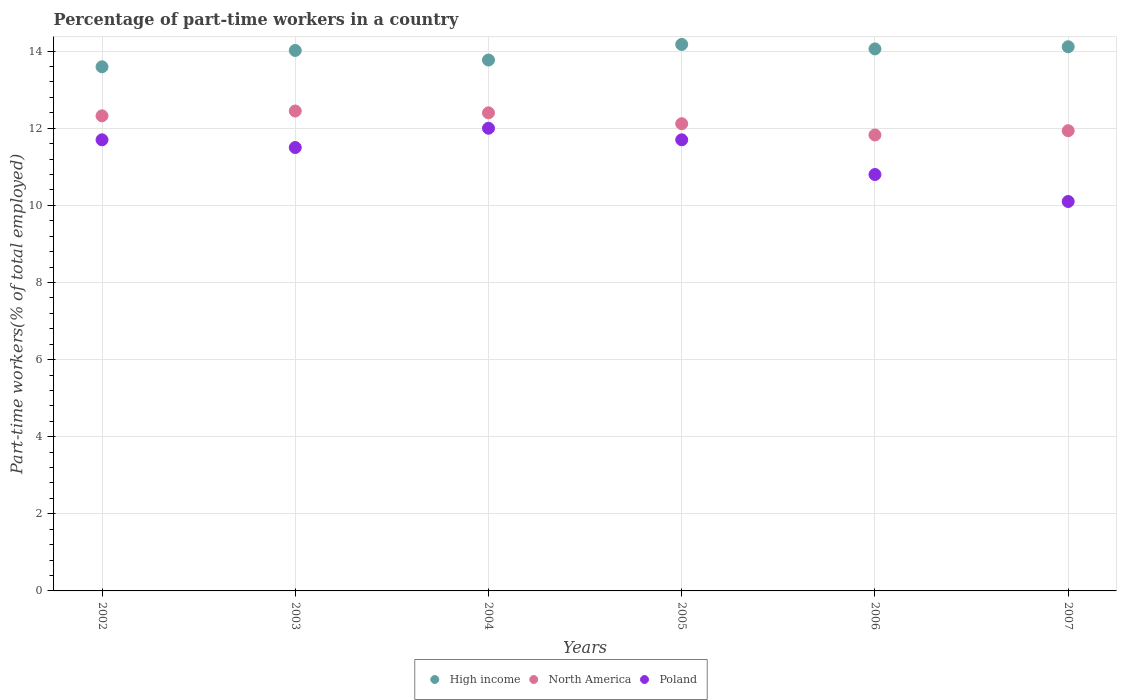Is the number of dotlines equal to the number of legend labels?
Give a very brief answer. Yes. Across all years, what is the minimum percentage of part-time workers in Poland?
Make the answer very short. 10.1. In which year was the percentage of part-time workers in Poland minimum?
Your answer should be very brief. 2007. What is the total percentage of part-time workers in Poland in the graph?
Make the answer very short. 67.8. What is the difference between the percentage of part-time workers in Poland in 2005 and that in 2006?
Make the answer very short. 0.9. What is the difference between the percentage of part-time workers in North America in 2006 and the percentage of part-time workers in Poland in 2004?
Your answer should be compact. -0.17. What is the average percentage of part-time workers in Poland per year?
Ensure brevity in your answer.  11.3. In the year 2007, what is the difference between the percentage of part-time workers in High income and percentage of part-time workers in Poland?
Your response must be concise. 4.01. In how many years, is the percentage of part-time workers in North America greater than 2.8 %?
Ensure brevity in your answer.  6. What is the ratio of the percentage of part-time workers in Poland in 2003 to that in 2006?
Make the answer very short. 1.06. What is the difference between the highest and the second highest percentage of part-time workers in Poland?
Provide a short and direct response. 0.3. What is the difference between the highest and the lowest percentage of part-time workers in Poland?
Offer a very short reply. 1.9. Is it the case that in every year, the sum of the percentage of part-time workers in North America and percentage of part-time workers in Poland  is greater than the percentage of part-time workers in High income?
Keep it short and to the point. Yes. Is the percentage of part-time workers in Poland strictly greater than the percentage of part-time workers in High income over the years?
Offer a very short reply. No. Is the percentage of part-time workers in Poland strictly less than the percentage of part-time workers in High income over the years?
Make the answer very short. Yes. How many dotlines are there?
Provide a succinct answer. 3. How many years are there in the graph?
Provide a short and direct response. 6. Does the graph contain grids?
Provide a short and direct response. Yes. Where does the legend appear in the graph?
Provide a succinct answer. Bottom center. How are the legend labels stacked?
Offer a terse response. Horizontal. What is the title of the graph?
Keep it short and to the point. Percentage of part-time workers in a country. Does "Brunei Darussalam" appear as one of the legend labels in the graph?
Ensure brevity in your answer.  No. What is the label or title of the Y-axis?
Your answer should be compact. Part-time workers(% of total employed). What is the Part-time workers(% of total employed) of High income in 2002?
Your answer should be compact. 13.59. What is the Part-time workers(% of total employed) of North America in 2002?
Offer a terse response. 12.32. What is the Part-time workers(% of total employed) of Poland in 2002?
Provide a short and direct response. 11.7. What is the Part-time workers(% of total employed) in High income in 2003?
Keep it short and to the point. 14.02. What is the Part-time workers(% of total employed) in North America in 2003?
Offer a terse response. 12.45. What is the Part-time workers(% of total employed) in Poland in 2003?
Your answer should be compact. 11.5. What is the Part-time workers(% of total employed) in High income in 2004?
Your answer should be very brief. 13.77. What is the Part-time workers(% of total employed) of North America in 2004?
Provide a succinct answer. 12.4. What is the Part-time workers(% of total employed) in High income in 2005?
Your response must be concise. 14.17. What is the Part-time workers(% of total employed) of North America in 2005?
Provide a short and direct response. 12.12. What is the Part-time workers(% of total employed) in Poland in 2005?
Keep it short and to the point. 11.7. What is the Part-time workers(% of total employed) of High income in 2006?
Provide a short and direct response. 14.06. What is the Part-time workers(% of total employed) in North America in 2006?
Offer a terse response. 11.83. What is the Part-time workers(% of total employed) in Poland in 2006?
Make the answer very short. 10.8. What is the Part-time workers(% of total employed) in High income in 2007?
Give a very brief answer. 14.11. What is the Part-time workers(% of total employed) in North America in 2007?
Your answer should be very brief. 11.94. What is the Part-time workers(% of total employed) in Poland in 2007?
Provide a short and direct response. 10.1. Across all years, what is the maximum Part-time workers(% of total employed) in High income?
Your response must be concise. 14.17. Across all years, what is the maximum Part-time workers(% of total employed) of North America?
Provide a short and direct response. 12.45. Across all years, what is the maximum Part-time workers(% of total employed) in Poland?
Provide a succinct answer. 12. Across all years, what is the minimum Part-time workers(% of total employed) in High income?
Give a very brief answer. 13.59. Across all years, what is the minimum Part-time workers(% of total employed) of North America?
Give a very brief answer. 11.83. Across all years, what is the minimum Part-time workers(% of total employed) in Poland?
Make the answer very short. 10.1. What is the total Part-time workers(% of total employed) of High income in the graph?
Provide a short and direct response. 83.73. What is the total Part-time workers(% of total employed) of North America in the graph?
Your response must be concise. 73.05. What is the total Part-time workers(% of total employed) in Poland in the graph?
Keep it short and to the point. 67.8. What is the difference between the Part-time workers(% of total employed) in High income in 2002 and that in 2003?
Offer a very short reply. -0.42. What is the difference between the Part-time workers(% of total employed) of North America in 2002 and that in 2003?
Give a very brief answer. -0.13. What is the difference between the Part-time workers(% of total employed) of Poland in 2002 and that in 2003?
Your response must be concise. 0.2. What is the difference between the Part-time workers(% of total employed) of High income in 2002 and that in 2004?
Give a very brief answer. -0.18. What is the difference between the Part-time workers(% of total employed) in North America in 2002 and that in 2004?
Give a very brief answer. -0.08. What is the difference between the Part-time workers(% of total employed) in Poland in 2002 and that in 2004?
Keep it short and to the point. -0.3. What is the difference between the Part-time workers(% of total employed) in High income in 2002 and that in 2005?
Keep it short and to the point. -0.58. What is the difference between the Part-time workers(% of total employed) in North America in 2002 and that in 2005?
Offer a terse response. 0.2. What is the difference between the Part-time workers(% of total employed) of Poland in 2002 and that in 2005?
Offer a very short reply. 0. What is the difference between the Part-time workers(% of total employed) in High income in 2002 and that in 2006?
Your response must be concise. -0.46. What is the difference between the Part-time workers(% of total employed) of North America in 2002 and that in 2006?
Your response must be concise. 0.5. What is the difference between the Part-time workers(% of total employed) in Poland in 2002 and that in 2006?
Your answer should be very brief. 0.9. What is the difference between the Part-time workers(% of total employed) of High income in 2002 and that in 2007?
Offer a terse response. -0.52. What is the difference between the Part-time workers(% of total employed) in North America in 2002 and that in 2007?
Ensure brevity in your answer.  0.39. What is the difference between the Part-time workers(% of total employed) in High income in 2003 and that in 2004?
Your response must be concise. 0.25. What is the difference between the Part-time workers(% of total employed) of North America in 2003 and that in 2004?
Your answer should be very brief. 0.05. What is the difference between the Part-time workers(% of total employed) of Poland in 2003 and that in 2004?
Give a very brief answer. -0.5. What is the difference between the Part-time workers(% of total employed) in High income in 2003 and that in 2005?
Offer a very short reply. -0.16. What is the difference between the Part-time workers(% of total employed) of North America in 2003 and that in 2005?
Provide a short and direct response. 0.33. What is the difference between the Part-time workers(% of total employed) in Poland in 2003 and that in 2005?
Offer a terse response. -0.2. What is the difference between the Part-time workers(% of total employed) in High income in 2003 and that in 2006?
Ensure brevity in your answer.  -0.04. What is the difference between the Part-time workers(% of total employed) of North America in 2003 and that in 2006?
Provide a short and direct response. 0.62. What is the difference between the Part-time workers(% of total employed) of High income in 2003 and that in 2007?
Your answer should be compact. -0.1. What is the difference between the Part-time workers(% of total employed) of North America in 2003 and that in 2007?
Your response must be concise. 0.51. What is the difference between the Part-time workers(% of total employed) of High income in 2004 and that in 2005?
Provide a short and direct response. -0.4. What is the difference between the Part-time workers(% of total employed) of North America in 2004 and that in 2005?
Provide a succinct answer. 0.28. What is the difference between the Part-time workers(% of total employed) in Poland in 2004 and that in 2005?
Provide a succinct answer. 0.3. What is the difference between the Part-time workers(% of total employed) of High income in 2004 and that in 2006?
Ensure brevity in your answer.  -0.29. What is the difference between the Part-time workers(% of total employed) of North America in 2004 and that in 2006?
Provide a short and direct response. 0.57. What is the difference between the Part-time workers(% of total employed) of High income in 2004 and that in 2007?
Offer a very short reply. -0.34. What is the difference between the Part-time workers(% of total employed) in North America in 2004 and that in 2007?
Give a very brief answer. 0.46. What is the difference between the Part-time workers(% of total employed) of High income in 2005 and that in 2006?
Provide a succinct answer. 0.12. What is the difference between the Part-time workers(% of total employed) of North America in 2005 and that in 2006?
Make the answer very short. 0.29. What is the difference between the Part-time workers(% of total employed) of High income in 2005 and that in 2007?
Offer a terse response. 0.06. What is the difference between the Part-time workers(% of total employed) of North America in 2005 and that in 2007?
Keep it short and to the point. 0.18. What is the difference between the Part-time workers(% of total employed) of Poland in 2005 and that in 2007?
Ensure brevity in your answer.  1.6. What is the difference between the Part-time workers(% of total employed) of High income in 2006 and that in 2007?
Your answer should be compact. -0.06. What is the difference between the Part-time workers(% of total employed) in North America in 2006 and that in 2007?
Your answer should be compact. -0.11. What is the difference between the Part-time workers(% of total employed) of High income in 2002 and the Part-time workers(% of total employed) of North America in 2003?
Give a very brief answer. 1.15. What is the difference between the Part-time workers(% of total employed) in High income in 2002 and the Part-time workers(% of total employed) in Poland in 2003?
Ensure brevity in your answer.  2.09. What is the difference between the Part-time workers(% of total employed) of North America in 2002 and the Part-time workers(% of total employed) of Poland in 2003?
Keep it short and to the point. 0.82. What is the difference between the Part-time workers(% of total employed) in High income in 2002 and the Part-time workers(% of total employed) in North America in 2004?
Keep it short and to the point. 1.19. What is the difference between the Part-time workers(% of total employed) in High income in 2002 and the Part-time workers(% of total employed) in Poland in 2004?
Provide a short and direct response. 1.59. What is the difference between the Part-time workers(% of total employed) in North America in 2002 and the Part-time workers(% of total employed) in Poland in 2004?
Make the answer very short. 0.32. What is the difference between the Part-time workers(% of total employed) of High income in 2002 and the Part-time workers(% of total employed) of North America in 2005?
Ensure brevity in your answer.  1.48. What is the difference between the Part-time workers(% of total employed) of High income in 2002 and the Part-time workers(% of total employed) of Poland in 2005?
Your answer should be compact. 1.89. What is the difference between the Part-time workers(% of total employed) of North America in 2002 and the Part-time workers(% of total employed) of Poland in 2005?
Provide a succinct answer. 0.62. What is the difference between the Part-time workers(% of total employed) in High income in 2002 and the Part-time workers(% of total employed) in North America in 2006?
Provide a short and direct response. 1.77. What is the difference between the Part-time workers(% of total employed) of High income in 2002 and the Part-time workers(% of total employed) of Poland in 2006?
Offer a terse response. 2.79. What is the difference between the Part-time workers(% of total employed) in North America in 2002 and the Part-time workers(% of total employed) in Poland in 2006?
Your response must be concise. 1.52. What is the difference between the Part-time workers(% of total employed) of High income in 2002 and the Part-time workers(% of total employed) of North America in 2007?
Make the answer very short. 1.66. What is the difference between the Part-time workers(% of total employed) in High income in 2002 and the Part-time workers(% of total employed) in Poland in 2007?
Your response must be concise. 3.49. What is the difference between the Part-time workers(% of total employed) in North America in 2002 and the Part-time workers(% of total employed) in Poland in 2007?
Provide a short and direct response. 2.22. What is the difference between the Part-time workers(% of total employed) in High income in 2003 and the Part-time workers(% of total employed) in North America in 2004?
Your answer should be very brief. 1.62. What is the difference between the Part-time workers(% of total employed) of High income in 2003 and the Part-time workers(% of total employed) of Poland in 2004?
Your response must be concise. 2.02. What is the difference between the Part-time workers(% of total employed) of North America in 2003 and the Part-time workers(% of total employed) of Poland in 2004?
Keep it short and to the point. 0.45. What is the difference between the Part-time workers(% of total employed) in High income in 2003 and the Part-time workers(% of total employed) in North America in 2005?
Keep it short and to the point. 1.9. What is the difference between the Part-time workers(% of total employed) of High income in 2003 and the Part-time workers(% of total employed) of Poland in 2005?
Provide a succinct answer. 2.32. What is the difference between the Part-time workers(% of total employed) in North America in 2003 and the Part-time workers(% of total employed) in Poland in 2005?
Your answer should be compact. 0.75. What is the difference between the Part-time workers(% of total employed) in High income in 2003 and the Part-time workers(% of total employed) in North America in 2006?
Make the answer very short. 2.19. What is the difference between the Part-time workers(% of total employed) of High income in 2003 and the Part-time workers(% of total employed) of Poland in 2006?
Provide a succinct answer. 3.22. What is the difference between the Part-time workers(% of total employed) of North America in 2003 and the Part-time workers(% of total employed) of Poland in 2006?
Your response must be concise. 1.65. What is the difference between the Part-time workers(% of total employed) of High income in 2003 and the Part-time workers(% of total employed) of North America in 2007?
Give a very brief answer. 2.08. What is the difference between the Part-time workers(% of total employed) of High income in 2003 and the Part-time workers(% of total employed) of Poland in 2007?
Keep it short and to the point. 3.92. What is the difference between the Part-time workers(% of total employed) in North America in 2003 and the Part-time workers(% of total employed) in Poland in 2007?
Make the answer very short. 2.35. What is the difference between the Part-time workers(% of total employed) of High income in 2004 and the Part-time workers(% of total employed) of North America in 2005?
Offer a very short reply. 1.65. What is the difference between the Part-time workers(% of total employed) of High income in 2004 and the Part-time workers(% of total employed) of Poland in 2005?
Provide a short and direct response. 2.07. What is the difference between the Part-time workers(% of total employed) of North America in 2004 and the Part-time workers(% of total employed) of Poland in 2005?
Provide a succinct answer. 0.7. What is the difference between the Part-time workers(% of total employed) of High income in 2004 and the Part-time workers(% of total employed) of North America in 2006?
Offer a very short reply. 1.94. What is the difference between the Part-time workers(% of total employed) in High income in 2004 and the Part-time workers(% of total employed) in Poland in 2006?
Your answer should be very brief. 2.97. What is the difference between the Part-time workers(% of total employed) in North America in 2004 and the Part-time workers(% of total employed) in Poland in 2006?
Provide a succinct answer. 1.6. What is the difference between the Part-time workers(% of total employed) in High income in 2004 and the Part-time workers(% of total employed) in North America in 2007?
Ensure brevity in your answer.  1.83. What is the difference between the Part-time workers(% of total employed) in High income in 2004 and the Part-time workers(% of total employed) in Poland in 2007?
Keep it short and to the point. 3.67. What is the difference between the Part-time workers(% of total employed) in North America in 2004 and the Part-time workers(% of total employed) in Poland in 2007?
Your answer should be compact. 2.3. What is the difference between the Part-time workers(% of total employed) of High income in 2005 and the Part-time workers(% of total employed) of North America in 2006?
Keep it short and to the point. 2.35. What is the difference between the Part-time workers(% of total employed) of High income in 2005 and the Part-time workers(% of total employed) of Poland in 2006?
Provide a short and direct response. 3.37. What is the difference between the Part-time workers(% of total employed) in North America in 2005 and the Part-time workers(% of total employed) in Poland in 2006?
Keep it short and to the point. 1.32. What is the difference between the Part-time workers(% of total employed) in High income in 2005 and the Part-time workers(% of total employed) in North America in 2007?
Your answer should be very brief. 2.24. What is the difference between the Part-time workers(% of total employed) of High income in 2005 and the Part-time workers(% of total employed) of Poland in 2007?
Your answer should be very brief. 4.07. What is the difference between the Part-time workers(% of total employed) in North America in 2005 and the Part-time workers(% of total employed) in Poland in 2007?
Ensure brevity in your answer.  2.02. What is the difference between the Part-time workers(% of total employed) of High income in 2006 and the Part-time workers(% of total employed) of North America in 2007?
Give a very brief answer. 2.12. What is the difference between the Part-time workers(% of total employed) of High income in 2006 and the Part-time workers(% of total employed) of Poland in 2007?
Your answer should be compact. 3.96. What is the difference between the Part-time workers(% of total employed) of North America in 2006 and the Part-time workers(% of total employed) of Poland in 2007?
Make the answer very short. 1.73. What is the average Part-time workers(% of total employed) in High income per year?
Your response must be concise. 13.95. What is the average Part-time workers(% of total employed) of North America per year?
Your answer should be compact. 12.17. What is the average Part-time workers(% of total employed) of Poland per year?
Ensure brevity in your answer.  11.3. In the year 2002, what is the difference between the Part-time workers(% of total employed) of High income and Part-time workers(% of total employed) of North America?
Give a very brief answer. 1.27. In the year 2002, what is the difference between the Part-time workers(% of total employed) in High income and Part-time workers(% of total employed) in Poland?
Your response must be concise. 1.89. In the year 2002, what is the difference between the Part-time workers(% of total employed) of North America and Part-time workers(% of total employed) of Poland?
Your answer should be compact. 0.62. In the year 2003, what is the difference between the Part-time workers(% of total employed) in High income and Part-time workers(% of total employed) in North America?
Give a very brief answer. 1.57. In the year 2003, what is the difference between the Part-time workers(% of total employed) of High income and Part-time workers(% of total employed) of Poland?
Your answer should be very brief. 2.52. In the year 2003, what is the difference between the Part-time workers(% of total employed) of North America and Part-time workers(% of total employed) of Poland?
Provide a succinct answer. 0.95. In the year 2004, what is the difference between the Part-time workers(% of total employed) in High income and Part-time workers(% of total employed) in North America?
Keep it short and to the point. 1.37. In the year 2004, what is the difference between the Part-time workers(% of total employed) of High income and Part-time workers(% of total employed) of Poland?
Offer a very short reply. 1.77. In the year 2004, what is the difference between the Part-time workers(% of total employed) in North America and Part-time workers(% of total employed) in Poland?
Keep it short and to the point. 0.4. In the year 2005, what is the difference between the Part-time workers(% of total employed) in High income and Part-time workers(% of total employed) in North America?
Provide a short and direct response. 2.06. In the year 2005, what is the difference between the Part-time workers(% of total employed) of High income and Part-time workers(% of total employed) of Poland?
Keep it short and to the point. 2.47. In the year 2005, what is the difference between the Part-time workers(% of total employed) of North America and Part-time workers(% of total employed) of Poland?
Provide a succinct answer. 0.42. In the year 2006, what is the difference between the Part-time workers(% of total employed) in High income and Part-time workers(% of total employed) in North America?
Keep it short and to the point. 2.23. In the year 2006, what is the difference between the Part-time workers(% of total employed) in High income and Part-time workers(% of total employed) in Poland?
Ensure brevity in your answer.  3.26. In the year 2006, what is the difference between the Part-time workers(% of total employed) of North America and Part-time workers(% of total employed) of Poland?
Give a very brief answer. 1.03. In the year 2007, what is the difference between the Part-time workers(% of total employed) in High income and Part-time workers(% of total employed) in North America?
Your response must be concise. 2.18. In the year 2007, what is the difference between the Part-time workers(% of total employed) of High income and Part-time workers(% of total employed) of Poland?
Ensure brevity in your answer.  4.01. In the year 2007, what is the difference between the Part-time workers(% of total employed) in North America and Part-time workers(% of total employed) in Poland?
Offer a terse response. 1.84. What is the ratio of the Part-time workers(% of total employed) of High income in 2002 to that in 2003?
Make the answer very short. 0.97. What is the ratio of the Part-time workers(% of total employed) of Poland in 2002 to that in 2003?
Offer a terse response. 1.02. What is the ratio of the Part-time workers(% of total employed) in High income in 2002 to that in 2004?
Ensure brevity in your answer.  0.99. What is the ratio of the Part-time workers(% of total employed) of Poland in 2002 to that in 2004?
Offer a terse response. 0.97. What is the ratio of the Part-time workers(% of total employed) of High income in 2002 to that in 2005?
Your answer should be compact. 0.96. What is the ratio of the Part-time workers(% of total employed) in North America in 2002 to that in 2005?
Provide a short and direct response. 1.02. What is the ratio of the Part-time workers(% of total employed) in Poland in 2002 to that in 2005?
Provide a short and direct response. 1. What is the ratio of the Part-time workers(% of total employed) in North America in 2002 to that in 2006?
Offer a terse response. 1.04. What is the ratio of the Part-time workers(% of total employed) of Poland in 2002 to that in 2006?
Your answer should be compact. 1.08. What is the ratio of the Part-time workers(% of total employed) in High income in 2002 to that in 2007?
Keep it short and to the point. 0.96. What is the ratio of the Part-time workers(% of total employed) in North America in 2002 to that in 2007?
Keep it short and to the point. 1.03. What is the ratio of the Part-time workers(% of total employed) of Poland in 2002 to that in 2007?
Your answer should be compact. 1.16. What is the ratio of the Part-time workers(% of total employed) in High income in 2003 to that in 2004?
Provide a short and direct response. 1.02. What is the ratio of the Part-time workers(% of total employed) in Poland in 2003 to that in 2004?
Offer a very short reply. 0.96. What is the ratio of the Part-time workers(% of total employed) in High income in 2003 to that in 2005?
Give a very brief answer. 0.99. What is the ratio of the Part-time workers(% of total employed) of North America in 2003 to that in 2005?
Provide a succinct answer. 1.03. What is the ratio of the Part-time workers(% of total employed) in Poland in 2003 to that in 2005?
Provide a succinct answer. 0.98. What is the ratio of the Part-time workers(% of total employed) of High income in 2003 to that in 2006?
Your answer should be compact. 1. What is the ratio of the Part-time workers(% of total employed) of North America in 2003 to that in 2006?
Your answer should be compact. 1.05. What is the ratio of the Part-time workers(% of total employed) of Poland in 2003 to that in 2006?
Your answer should be compact. 1.06. What is the ratio of the Part-time workers(% of total employed) in North America in 2003 to that in 2007?
Provide a short and direct response. 1.04. What is the ratio of the Part-time workers(% of total employed) of Poland in 2003 to that in 2007?
Keep it short and to the point. 1.14. What is the ratio of the Part-time workers(% of total employed) of High income in 2004 to that in 2005?
Your answer should be very brief. 0.97. What is the ratio of the Part-time workers(% of total employed) of North America in 2004 to that in 2005?
Your answer should be compact. 1.02. What is the ratio of the Part-time workers(% of total employed) of Poland in 2004 to that in 2005?
Your response must be concise. 1.03. What is the ratio of the Part-time workers(% of total employed) of High income in 2004 to that in 2006?
Give a very brief answer. 0.98. What is the ratio of the Part-time workers(% of total employed) in North America in 2004 to that in 2006?
Your answer should be compact. 1.05. What is the ratio of the Part-time workers(% of total employed) in High income in 2004 to that in 2007?
Offer a terse response. 0.98. What is the ratio of the Part-time workers(% of total employed) in North America in 2004 to that in 2007?
Your answer should be compact. 1.04. What is the ratio of the Part-time workers(% of total employed) in Poland in 2004 to that in 2007?
Provide a short and direct response. 1.19. What is the ratio of the Part-time workers(% of total employed) in High income in 2005 to that in 2006?
Your answer should be very brief. 1.01. What is the ratio of the Part-time workers(% of total employed) in North America in 2005 to that in 2006?
Offer a very short reply. 1.02. What is the ratio of the Part-time workers(% of total employed) in High income in 2005 to that in 2007?
Your answer should be very brief. 1. What is the ratio of the Part-time workers(% of total employed) of North America in 2005 to that in 2007?
Your answer should be compact. 1.02. What is the ratio of the Part-time workers(% of total employed) in Poland in 2005 to that in 2007?
Your answer should be very brief. 1.16. What is the ratio of the Part-time workers(% of total employed) in High income in 2006 to that in 2007?
Give a very brief answer. 1. What is the ratio of the Part-time workers(% of total employed) in Poland in 2006 to that in 2007?
Ensure brevity in your answer.  1.07. What is the difference between the highest and the second highest Part-time workers(% of total employed) of High income?
Your response must be concise. 0.06. What is the difference between the highest and the second highest Part-time workers(% of total employed) in North America?
Ensure brevity in your answer.  0.05. What is the difference between the highest and the lowest Part-time workers(% of total employed) in High income?
Keep it short and to the point. 0.58. What is the difference between the highest and the lowest Part-time workers(% of total employed) of North America?
Your answer should be very brief. 0.62. What is the difference between the highest and the lowest Part-time workers(% of total employed) of Poland?
Ensure brevity in your answer.  1.9. 